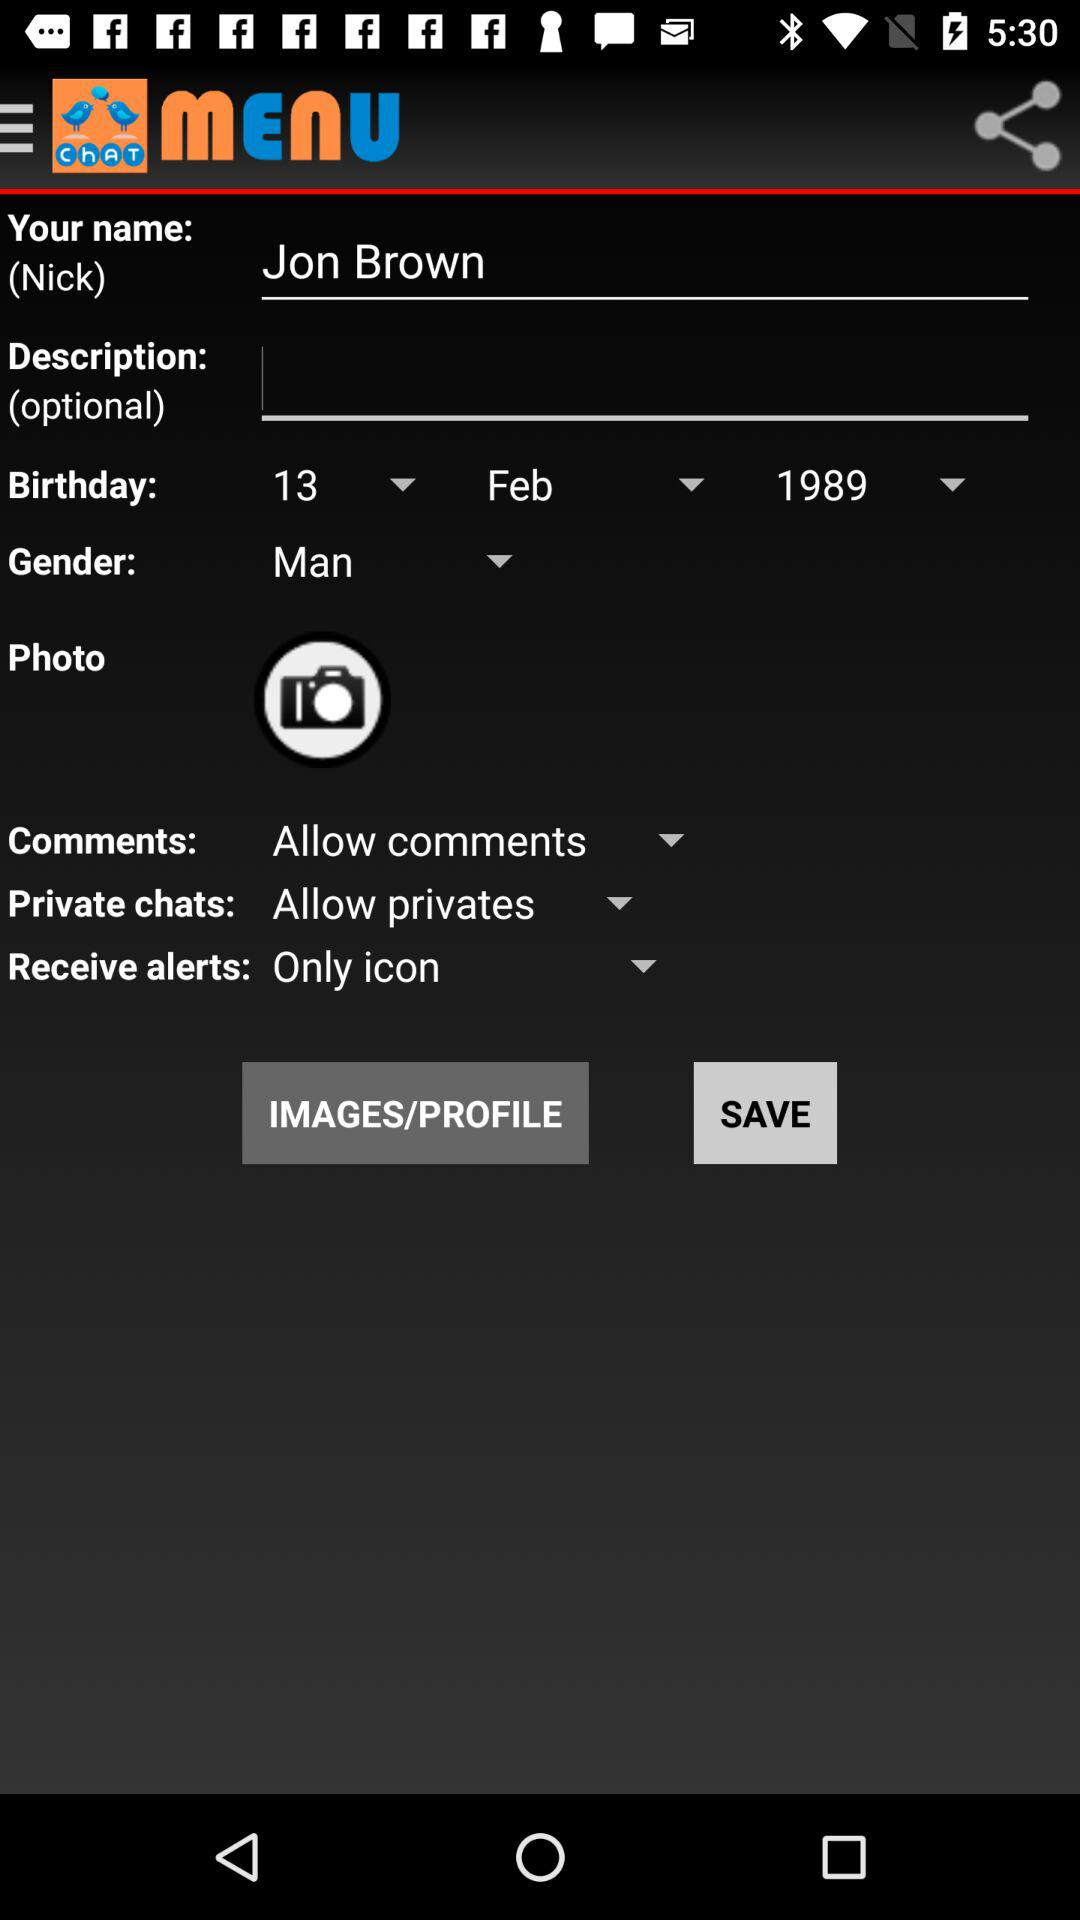What is the selected gender? The selected gender is man. 